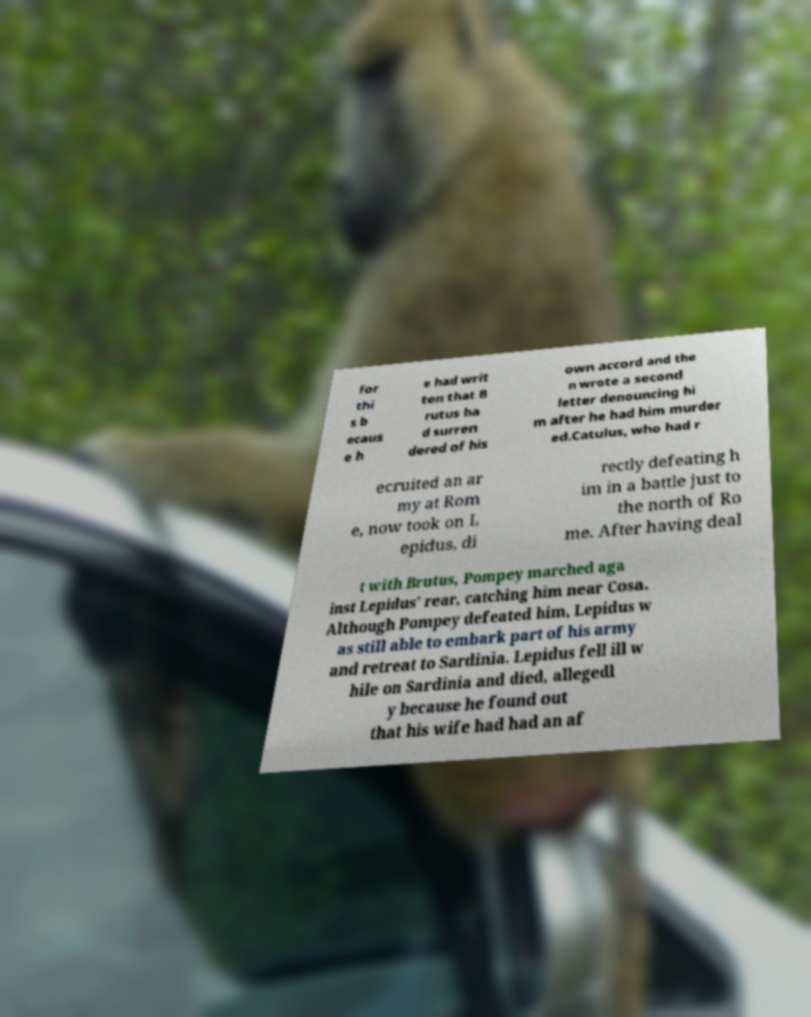What messages or text are displayed in this image? I need them in a readable, typed format. for thi s b ecaus e h e had writ ten that B rutus ha d surren dered of his own accord and the n wrote a second letter denouncing hi m after he had him murder ed.Catulus, who had r ecruited an ar my at Rom e, now took on L epidus, di rectly defeating h im in a battle just to the north of Ro me. After having deal t with Brutus, Pompey marched aga inst Lepidus' rear, catching him near Cosa. Although Pompey defeated him, Lepidus w as still able to embark part of his army and retreat to Sardinia. Lepidus fell ill w hile on Sardinia and died, allegedl y because he found out that his wife had had an af 